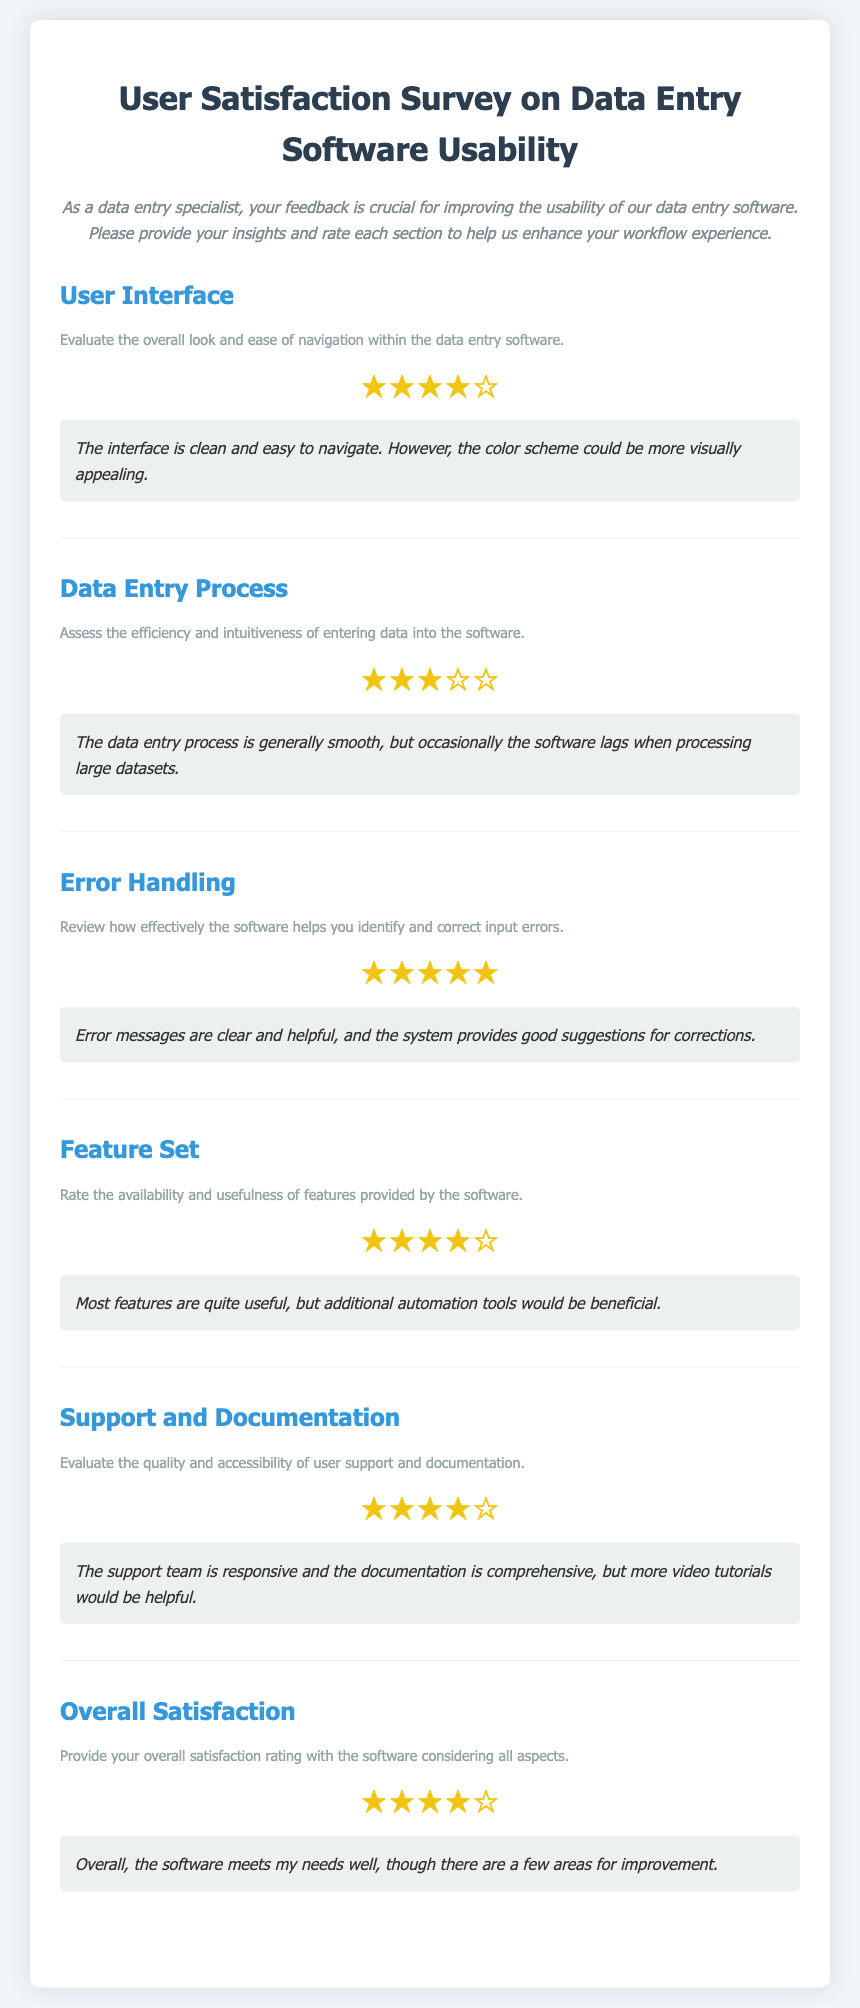What is the rating for User Interface? The rating for User Interface is indicated by four filled stars and one empty star.
Answer: ★★★★☆ What is the main comment for the Data Entry Process? The comment for the Data Entry Process highlights that the software occasionally lags when processing large datasets.
Answer: The data entry process is generally smooth, but occasionally the software lags when processing large datasets How many stars were awarded for Error Handling? The stars awarded for Error Handling are five filled stars, indicating a perfect score.
Answer: ★★★★★ What suggestion was made regarding the Feature Set? The suggestion related to the Feature Set mentions the need for additional automation tools.
Answer: Additional automation tools would be beneficial How does the support team respond according to the document? The document states that the support team is responsive.
Answer: The support team is responsive 